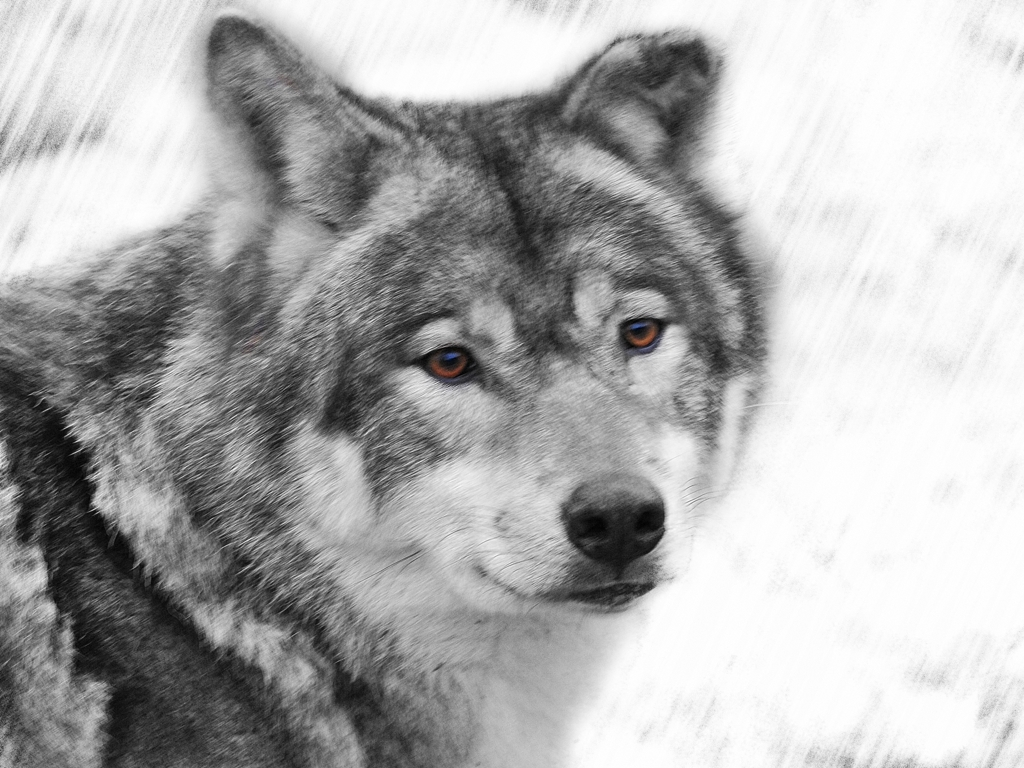What mood does this image convey? The image conveys a sense of intensity and focus, primarily through the wolf's direct and engaging gaze. The monochromatic background emphasizes the subject further, contributing to a solemn and contemplative mood. Does the wolf appear to be in its natural environment? The background appears to be intentionally blurred and desaturated, likely through digital manipulation, hence it doesn't provide enough context to determine the naturalness of the environment. 